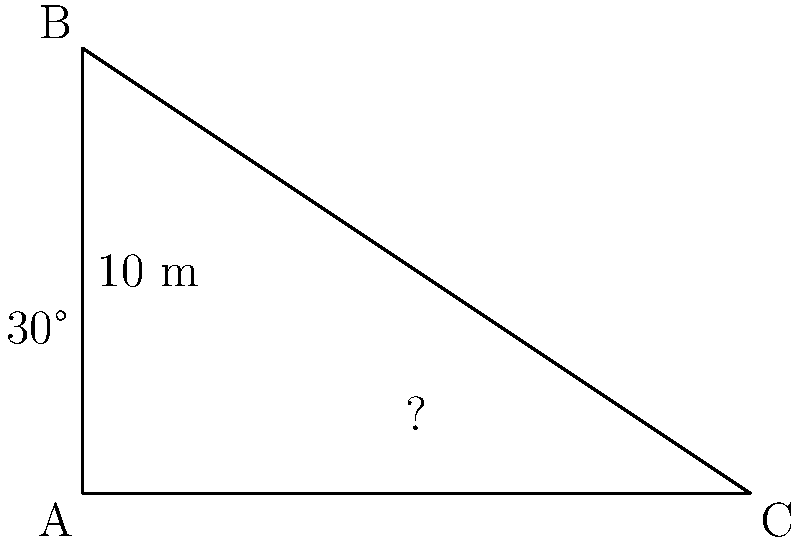During a tour of a medieval castle, you're explaining the mechanics of a drawbridge. The castle wall is 10 meters high, and when lowered, the drawbridge forms a 30-degree angle with the ground. What is the length of the drawbridge to the nearest meter? To solve this problem, we can use trigonometry. Let's approach this step-by-step:

1) First, let's identify what we know:
   - The height of the castle wall is 10 meters
   - The angle between the drawbridge and the ground is 30°

2) We can treat this as a right-angled triangle, where:
   - The castle wall is the opposite side
   - The drawbridge is the hypotenuse
   - The angle we're given is the angle between the ground and the drawbridge

3) We need to find the hypotenuse (drawbridge length). We can use the sine function:

   $\sin(\theta) = \frac{\text{opposite}}{\text{hypotenuse}}$

4) Plugging in our values:

   $\sin(30°) = \frac{10}{\text{drawbridge length}}$

5) We know that $\sin(30°) = \frac{1}{2}$, so our equation becomes:

   $\frac{1}{2} = \frac{10}{\text{drawbridge length}}$

6) Cross multiply:

   $\text{drawbridge length} \cdot \frac{1}{2} = 10$

7) Solve for the drawbridge length:

   $\text{drawbridge length} = 10 \cdot 2 = 20$

8) Therefore, the length of the drawbridge is 20 meters.
Answer: 20 m 